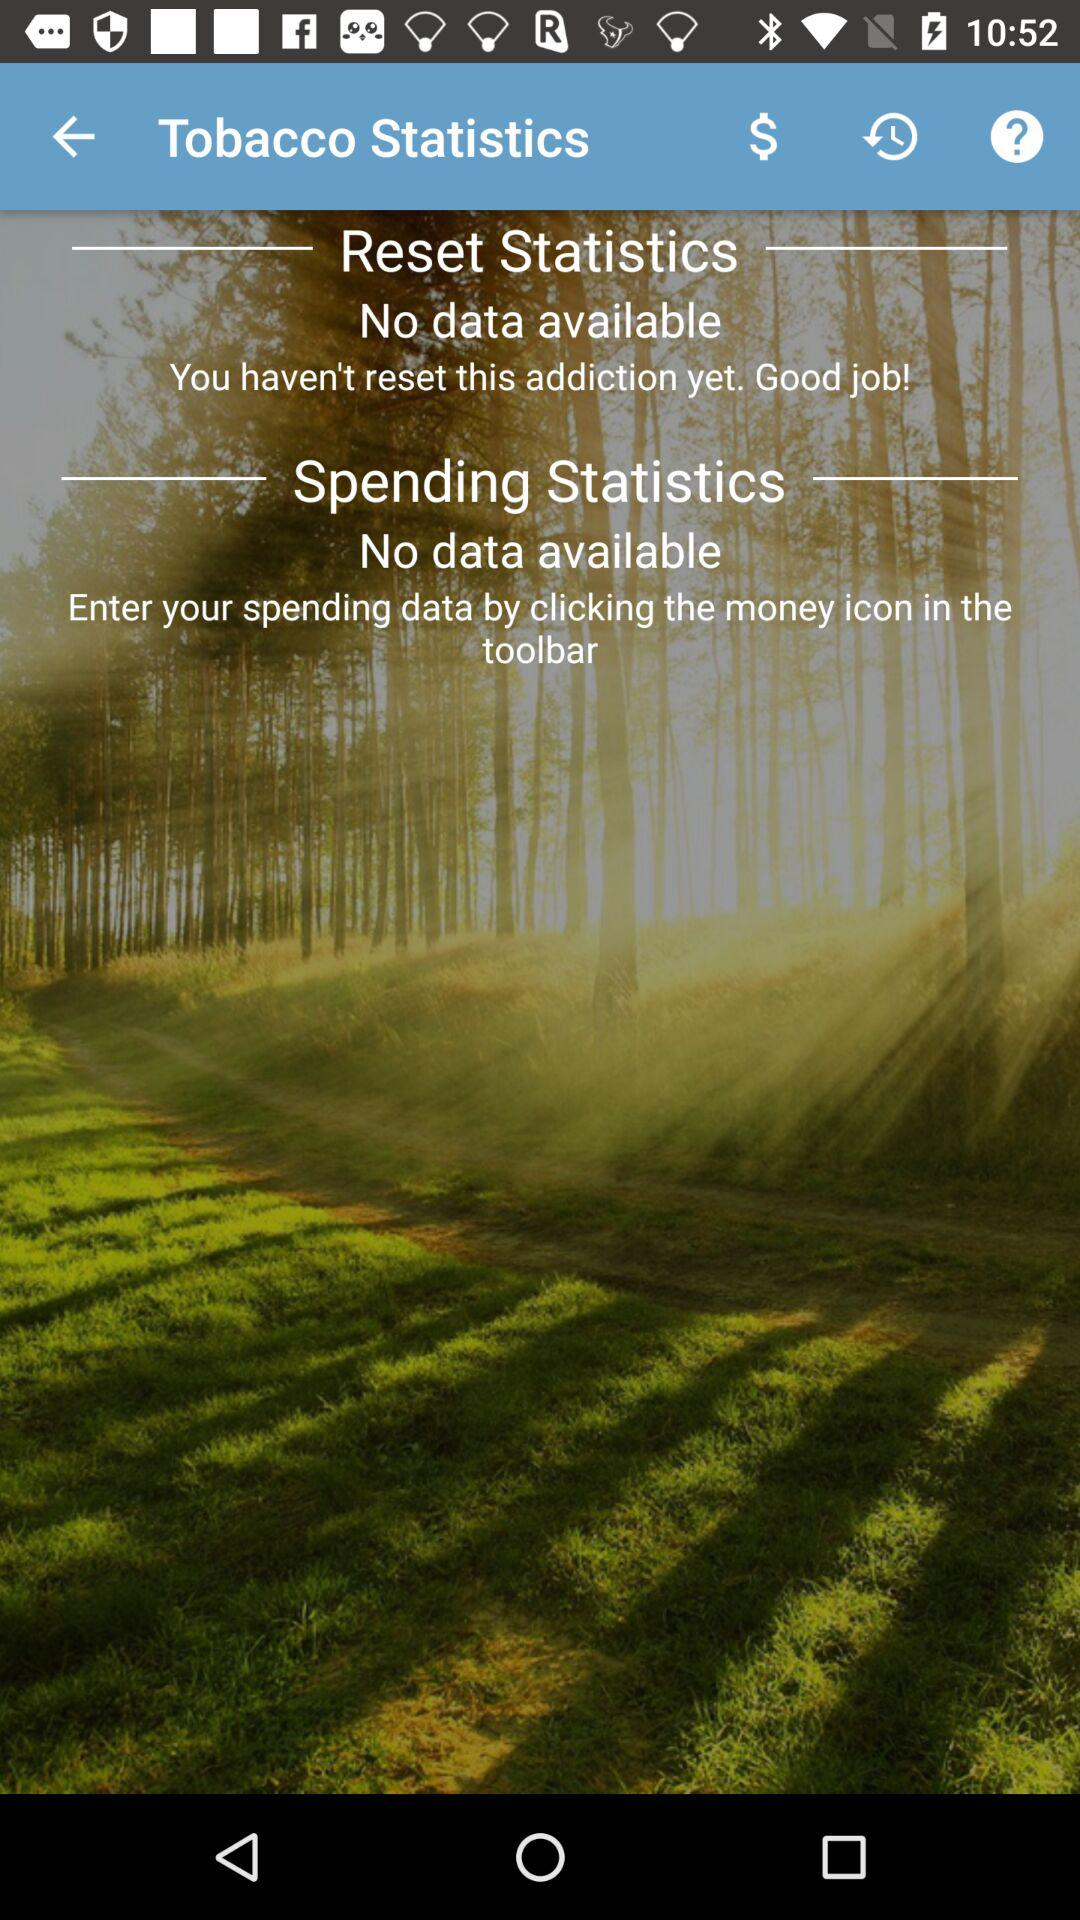What features can I use in this app to track my progress in quitting smoking? The app provides sections for 'Reset Statistics' to start afresh with your quitting journey, and 'Spending Statistics' to monitor the financial benefits of not purchasing tobacco products. You can begin tracking by entering data through the money icon indicated in the toolbar. How can resetting statistics help me in quitting smoking? Resetting statistics can serve as a motivational tool, providing a clean slate if you've had a setback. It allows you to visualize and track continuous progress from the point of reset, possibly reinforcing your commitment to quit. 